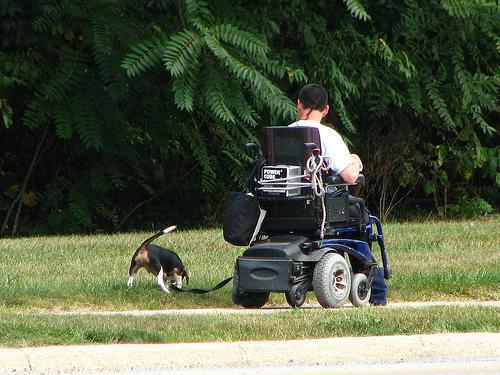How many people are there?
Give a very brief answer. 1. 